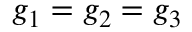Convert formula to latex. <formula><loc_0><loc_0><loc_500><loc_500>g _ { 1 } = g _ { 2 } = g _ { 3 }</formula> 